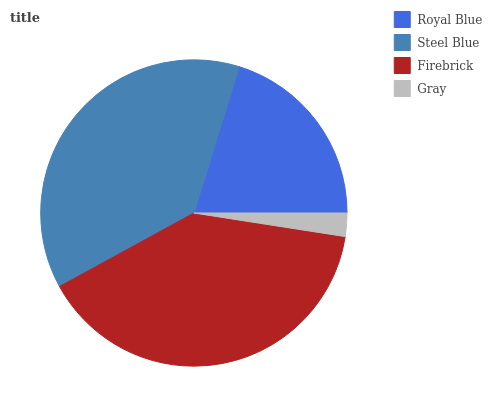Is Gray the minimum?
Answer yes or no. Yes. Is Firebrick the maximum?
Answer yes or no. Yes. Is Steel Blue the minimum?
Answer yes or no. No. Is Steel Blue the maximum?
Answer yes or no. No. Is Steel Blue greater than Royal Blue?
Answer yes or no. Yes. Is Royal Blue less than Steel Blue?
Answer yes or no. Yes. Is Royal Blue greater than Steel Blue?
Answer yes or no. No. Is Steel Blue less than Royal Blue?
Answer yes or no. No. Is Steel Blue the high median?
Answer yes or no. Yes. Is Royal Blue the low median?
Answer yes or no. Yes. Is Firebrick the high median?
Answer yes or no. No. Is Firebrick the low median?
Answer yes or no. No. 